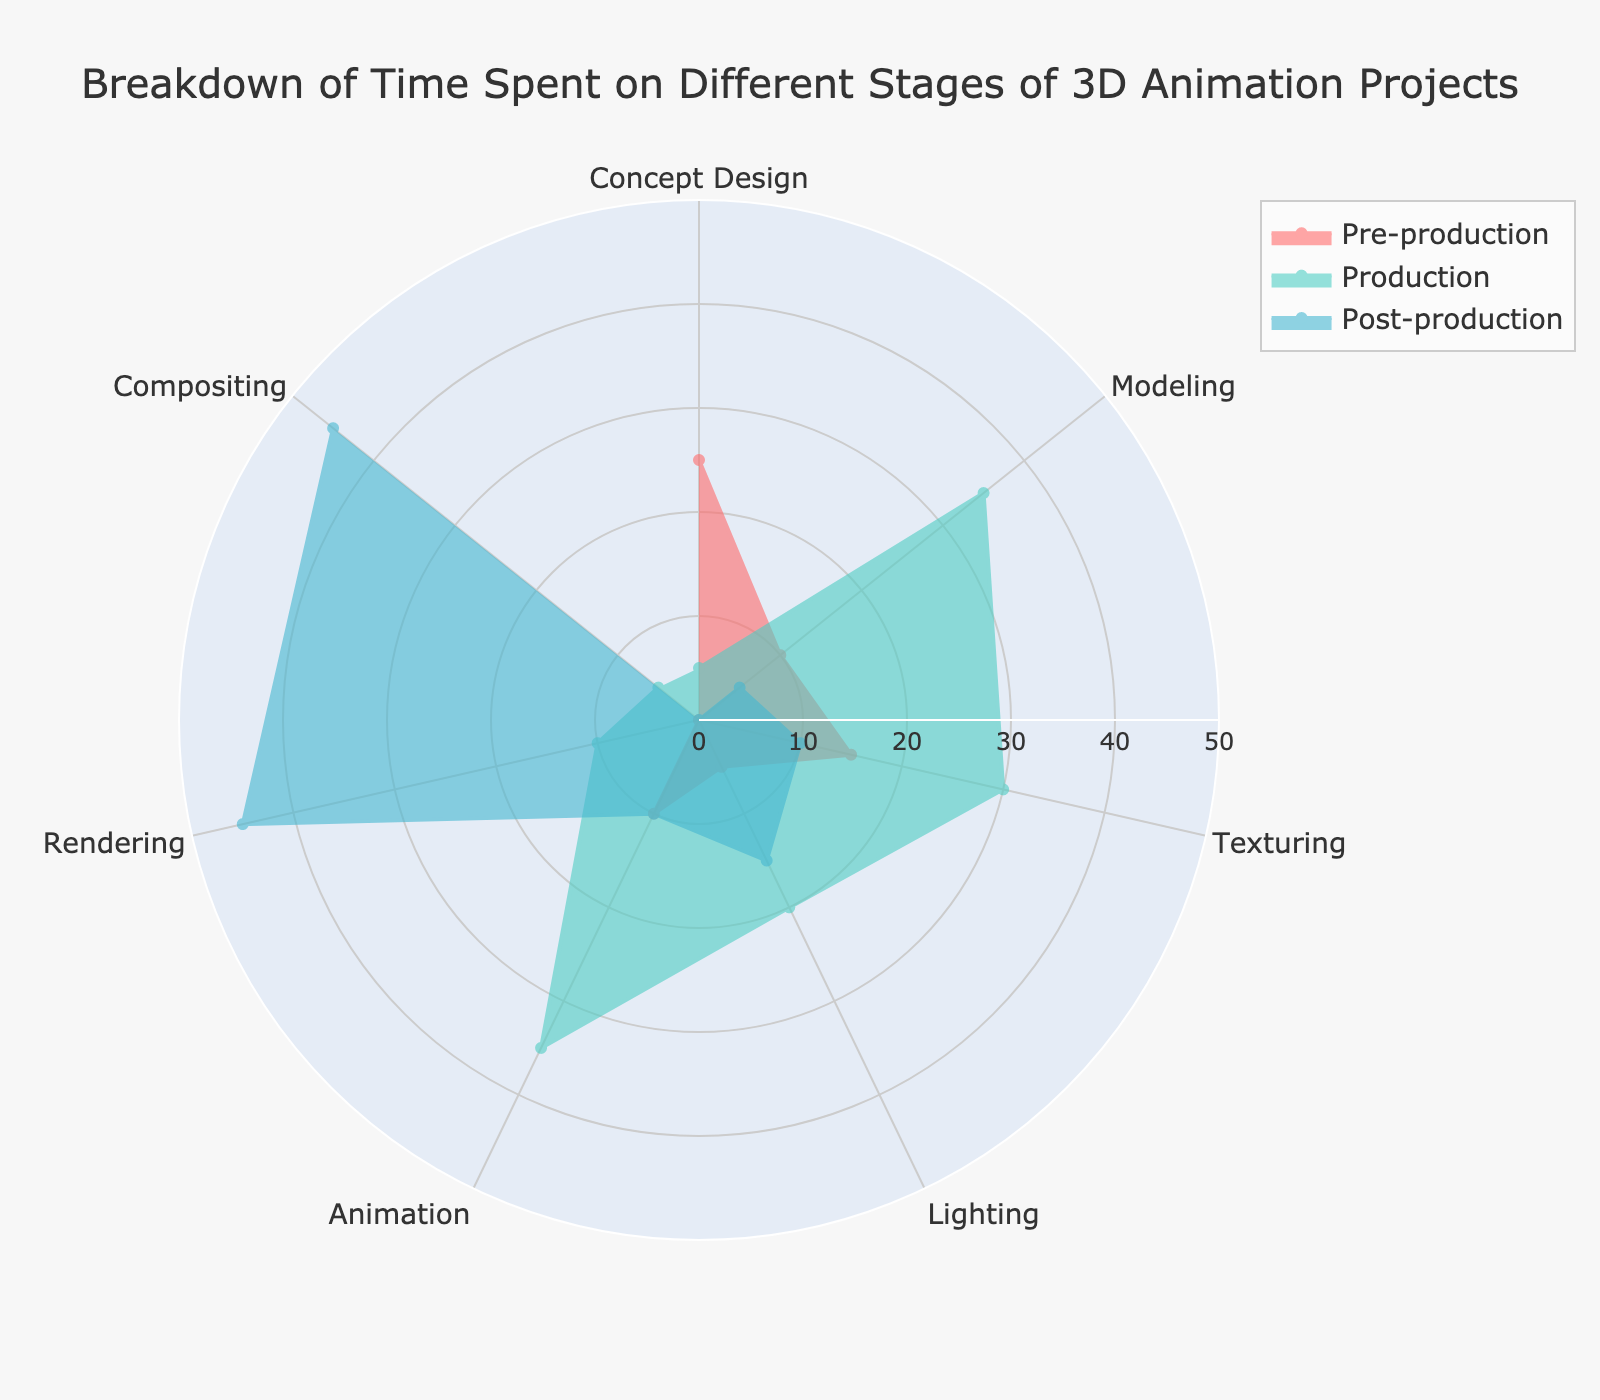What is the title of the radar chart? The title of the radar chart is usually at the top of the figure and describes the data being presented.
Answer: Breakdown of Time Spent on Different Stages of 3D Animation Projects Which stage spends the most time on Modeling? By examining the radar chart, you can see the data point for Modeling is the highest under the Production stage.
Answer: Production In which stage is Compositing equally important as Rendering? Compare the values for Compositing and Rendering across all stages and find one where they match. Both Compositing and Rendering have values of 45 in the Post-production stage.
Answer: Post-production What is the average time spent on Concept Design across all stages? Calculate the average by adding the values of Concept Design across all stages and dividing by the number of stages: (25 + 5 + 0) / 3.
Answer: 10 Which stage allocates the most time to Animation? Look at the values for Animation in each stage and identify the highest one. The highest value for Animation can be found in the Production stage at 35.
Answer: Production Compare the time spent on Texturing in Pre-production and Post-production. Which is higher and by how much? The time spent on Texturing in Pre-production is 15, while in Post-production, it is 10. The difference is 15 - 10.
Answer: Pre-production, by 5 What is the sum of time spent on Lighting in all stages? Add the values for Lighting across all stages: 5 (Pre-production) + 20 (Production) + 15 (Post-production) = 40.
Answer: 40 Which stage has the lowest overall time allocation? Summing up the values for each stage gives you the totals: Pre-production (25+10+15+5+10+0+0 = 65), Production (5+35+30+20+35+10+5 = 140), Post-production (0+5+10+15+10+45+45 = 130). The stage with the lowest total is Pre-production.
Answer: Pre-production In which stage is Rendering relatively least important? Identify the stage with the lowest value for Rendering. Pre-production has a value of 0 for Rendering, making it the least important in that stage.
Answer: Pre-production 